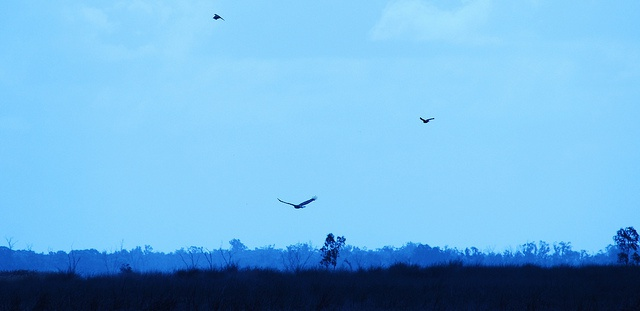Describe the objects in this image and their specific colors. I can see bird in lightblue, navy, darkblue, and blue tones, bird in lightblue, navy, gray, and blue tones, and bird in lightblue, black, navy, blue, and darkblue tones in this image. 